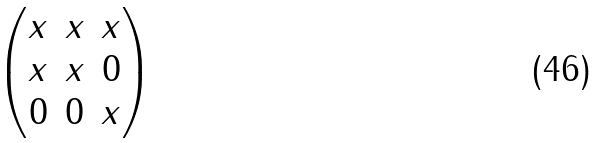<formula> <loc_0><loc_0><loc_500><loc_500>\begin{pmatrix} x & x & x \\ x & x & 0 \\ 0 & 0 & x \\ \end{pmatrix}</formula> 